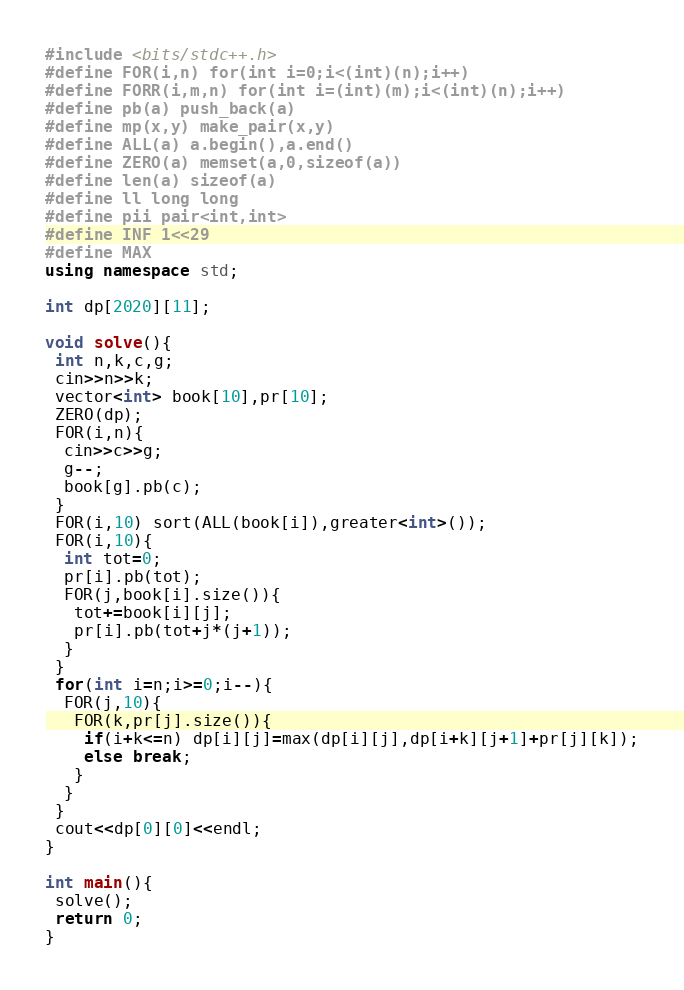Convert code to text. <code><loc_0><loc_0><loc_500><loc_500><_C++_>#include <bits/stdc++.h>
#define FOR(i,n) for(int i=0;i<(int)(n);i++)
#define FORR(i,m,n) for(int i=(int)(m);i<(int)(n);i++)
#define pb(a) push_back(a)
#define mp(x,y) make_pair(x,y)
#define ALL(a) a.begin(),a.end()
#define ZERO(a) memset(a,0,sizeof(a))
#define len(a) sizeof(a)
#define ll long long
#define pii pair<int,int>
#define INF 1<<29
#define MAX 
using namespace std;

int dp[2020][11];

void solve(){
 int n,k,c,g;
 cin>>n>>k;
 vector<int> book[10],pr[10];
 ZERO(dp);
 FOR(i,n){
  cin>>c>>g;
  g--;
  book[g].pb(c);
 }
 FOR(i,10) sort(ALL(book[i]),greater<int>());
 FOR(i,10){
  int tot=0;
  pr[i].pb(tot);
  FOR(j,book[i].size()){
   tot+=book[i][j];
   pr[i].pb(tot+j*(j+1));
  }
 }
 for(int i=n;i>=0;i--){
  FOR(j,10){
   FOR(k,pr[j].size()){
    if(i+k<=n) dp[i][j]=max(dp[i][j],dp[i+k][j+1]+pr[j][k]);
    else break;
   }
  }
 }
 cout<<dp[0][0]<<endl;
}

int main(){
 solve();
 return 0;
}</code> 